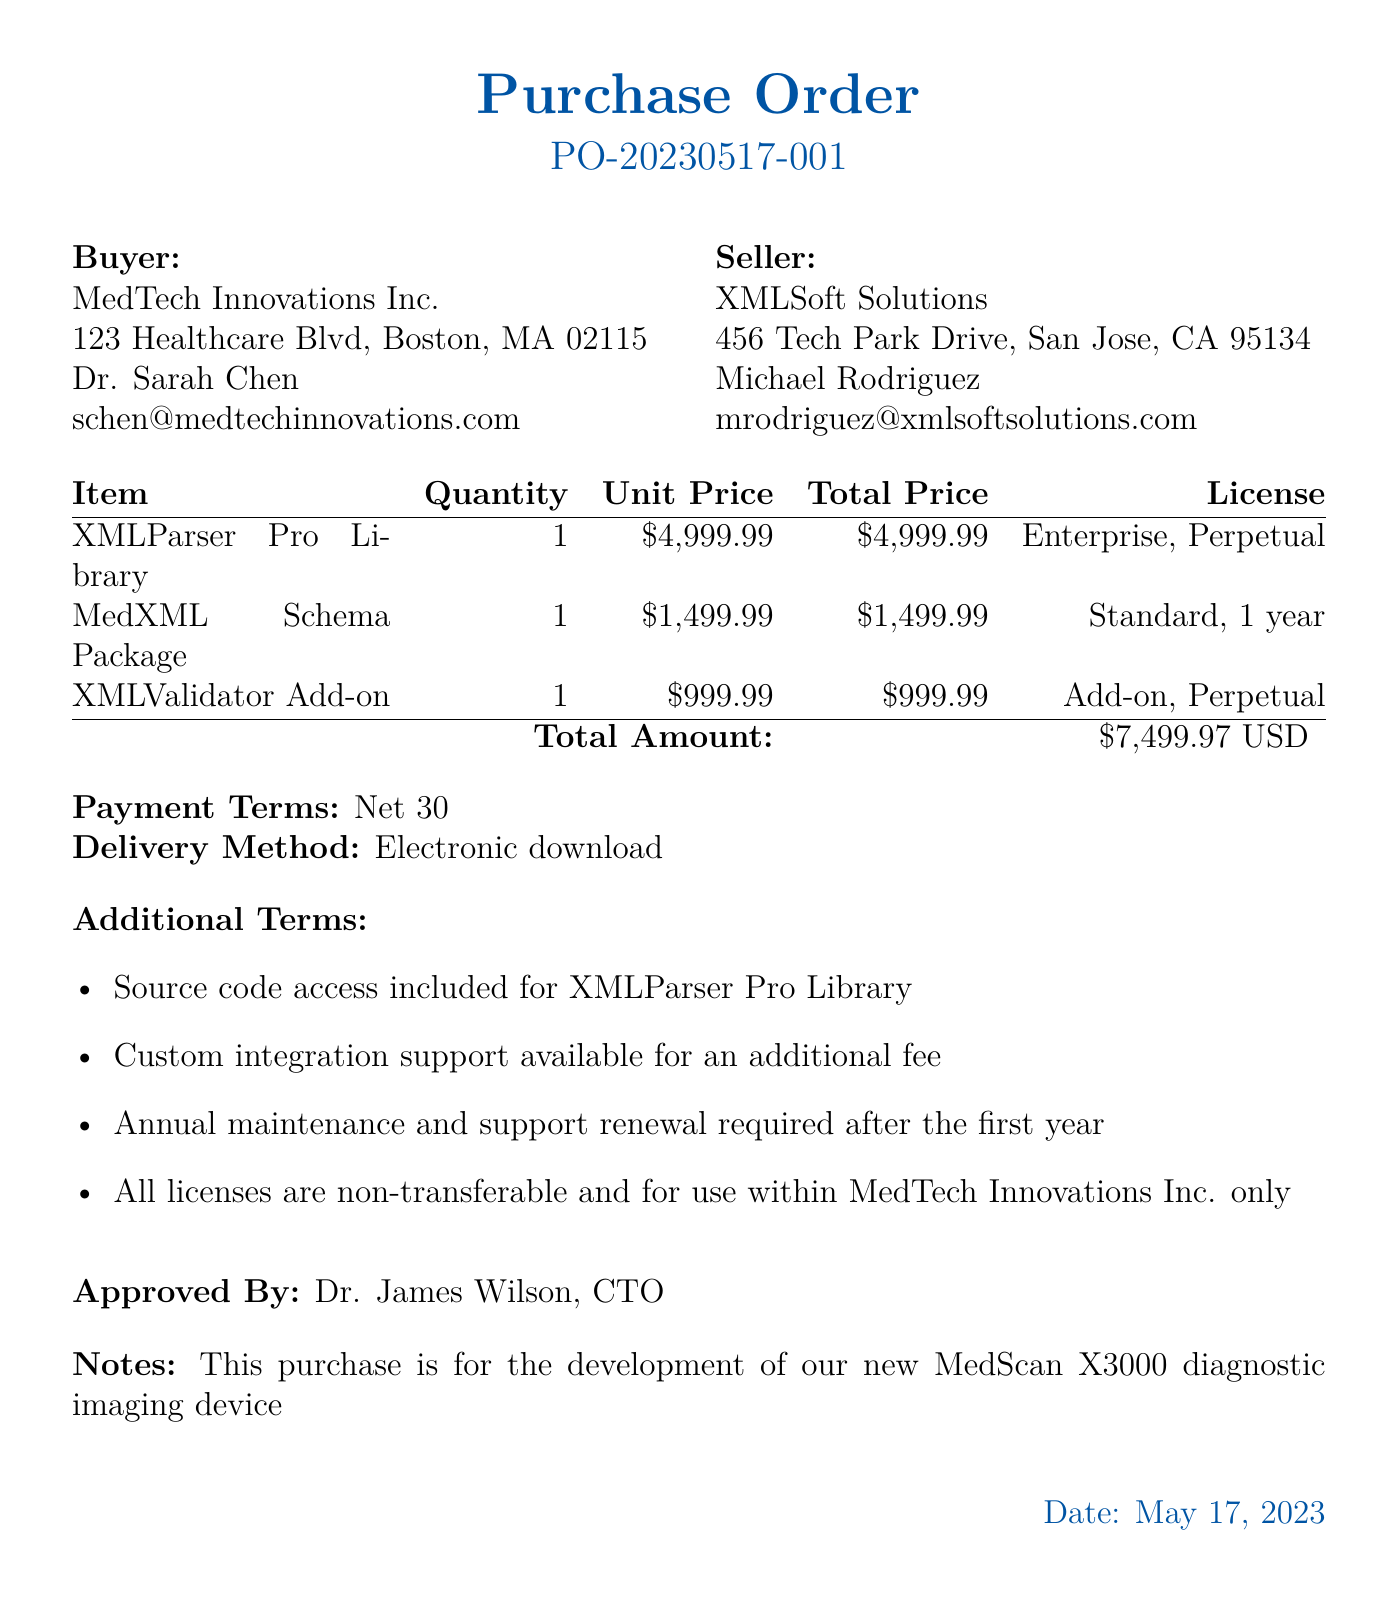what is the order number? The order number is clearly stated in the document as PO-20230517-001.
Answer: PO-20230517-001 who is the contact person for the buyer? The document lists Dr. Sarah Chen as the contact person for the buyer, MedTech Innovations Inc.
Answer: Dr. Sarah Chen what is the total amount of the purchase order? The total amount is specified in the document as the cumulative cost of all items listed, which totals $7499.97.
Answer: $7499.97 how long is the support period for the XMLParser Pro Library? The support period for the XMLParser Pro Library is detailed in the document as 1 year.
Answer: 1 year which delivery method is outlined in the document? The document specifies that the delivery method for the purchase is "Electronic download."
Answer: Electronic download what license type is associated with the MedXML Schema Package? The license type for the MedXML Schema Package is labeled as "Standard" in the document.
Answer: Standard how many users can use the XMLValidator Add-on? The document states that the XMLValidator Add-on has an unlimited number of users, as indicated in the license details.
Answer: Unlimited who approved the purchase order? The document indicates that the purchase order was approved by Dr. James Wilson, the CTO.
Answer: Dr. James Wilson what additional term is mentioned about the licenses? One additional term states that "All licenses are non-transferable and for use within MedTech Innovations Inc. only."
Answer: Non-transferable 